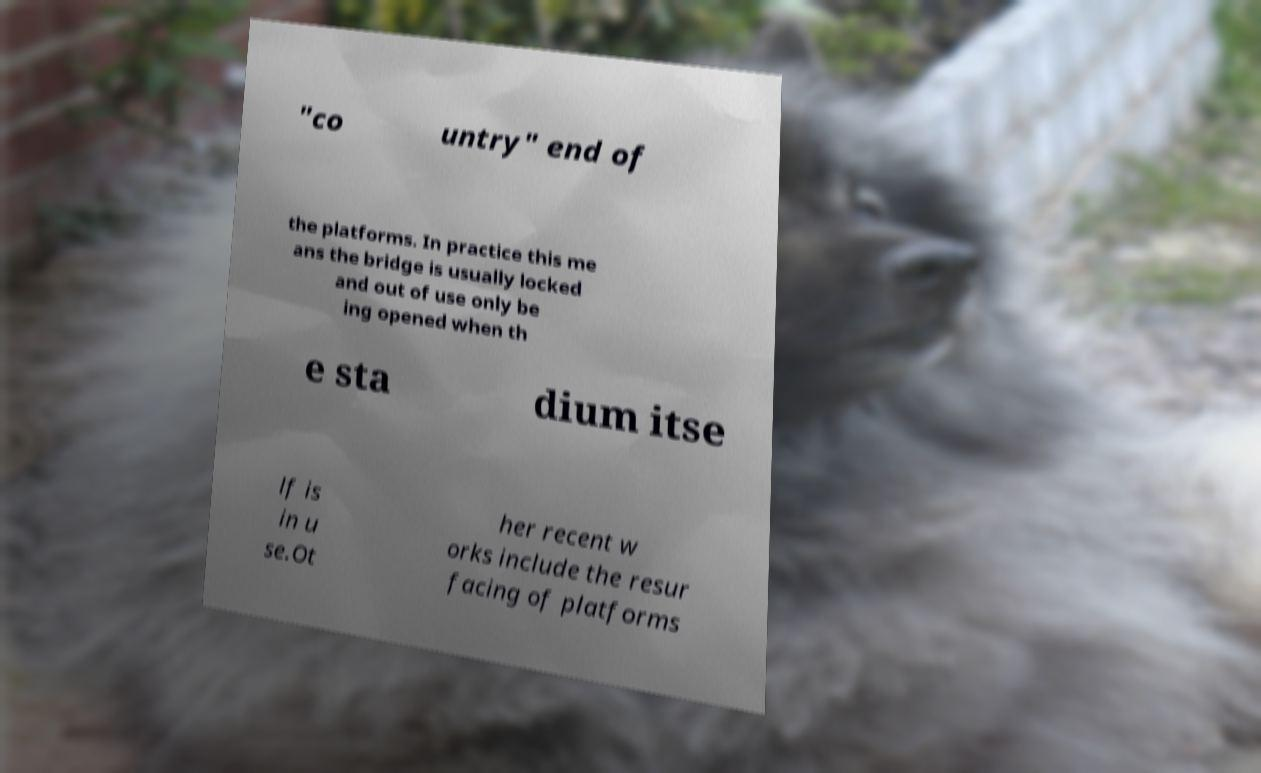Could you extract and type out the text from this image? "co untry" end of the platforms. In practice this me ans the bridge is usually locked and out of use only be ing opened when th e sta dium itse lf is in u se.Ot her recent w orks include the resur facing of platforms 